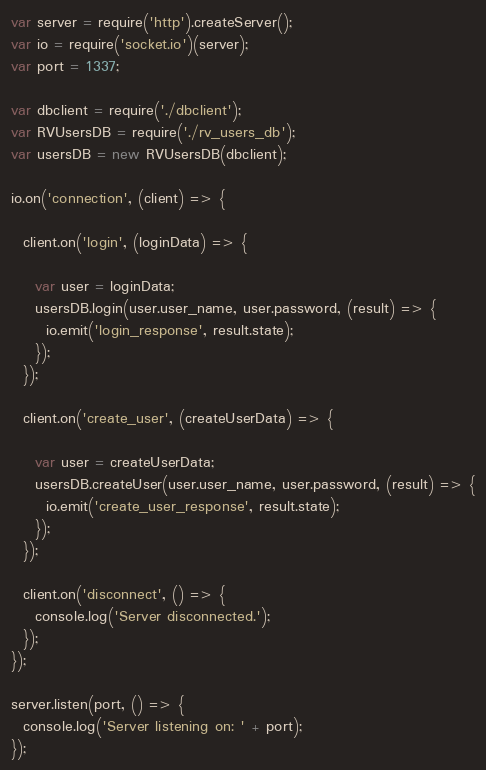<code> <loc_0><loc_0><loc_500><loc_500><_JavaScript_>var server = require('http').createServer();
var io = require('socket.io')(server);
var port = 1337;

var dbclient = require('./dbclient');
var RVUsersDB = require('./rv_users_db');
var usersDB = new RVUsersDB(dbclient);

io.on('connection', (client) => {

  client.on('login', (loginData) => {

    var user = loginData;
    usersDB.login(user.user_name, user.password, (result) => {
      io.emit('login_response', result.state);
    });
  });

  client.on('create_user', (createUserData) => {

    var user = createUserData;
    usersDB.createUser(user.user_name, user.password, (result) => {
      io.emit('create_user_response', result.state);      
    });
  });

  client.on('disconnect', () => {
    console.log('Server disconnected.');
  });
});

server.listen(port, () => {
  console.log('Server listening on: ' + port);
});
</code> 